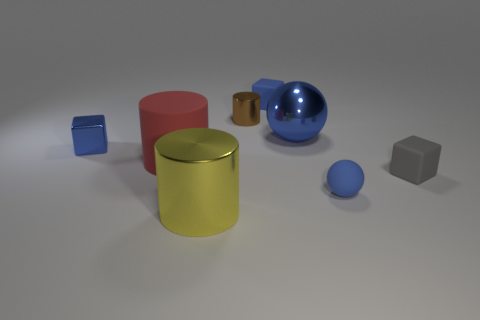How many blue balls must be subtracted to get 1 blue balls? 1 Subtract all green cylinders. Subtract all blue cubes. How many cylinders are left? 3 Add 1 yellow cylinders. How many objects exist? 9 Subtract all cylinders. How many objects are left? 5 Add 5 large red cylinders. How many large red cylinders are left? 6 Add 3 blue matte spheres. How many blue matte spheres exist? 4 Subtract 0 red blocks. How many objects are left? 8 Subtract all red cylinders. Subtract all small gray objects. How many objects are left? 6 